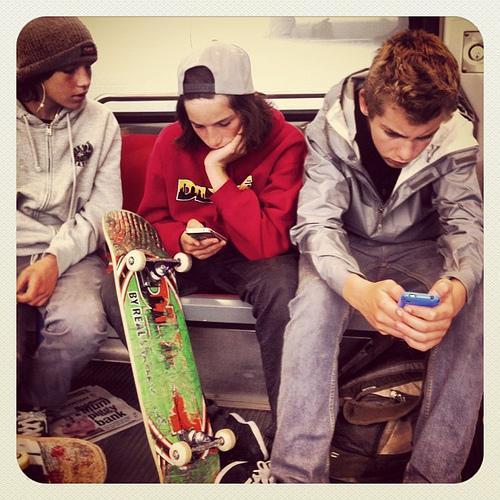How many boys are there?
Give a very brief answer. 3. 